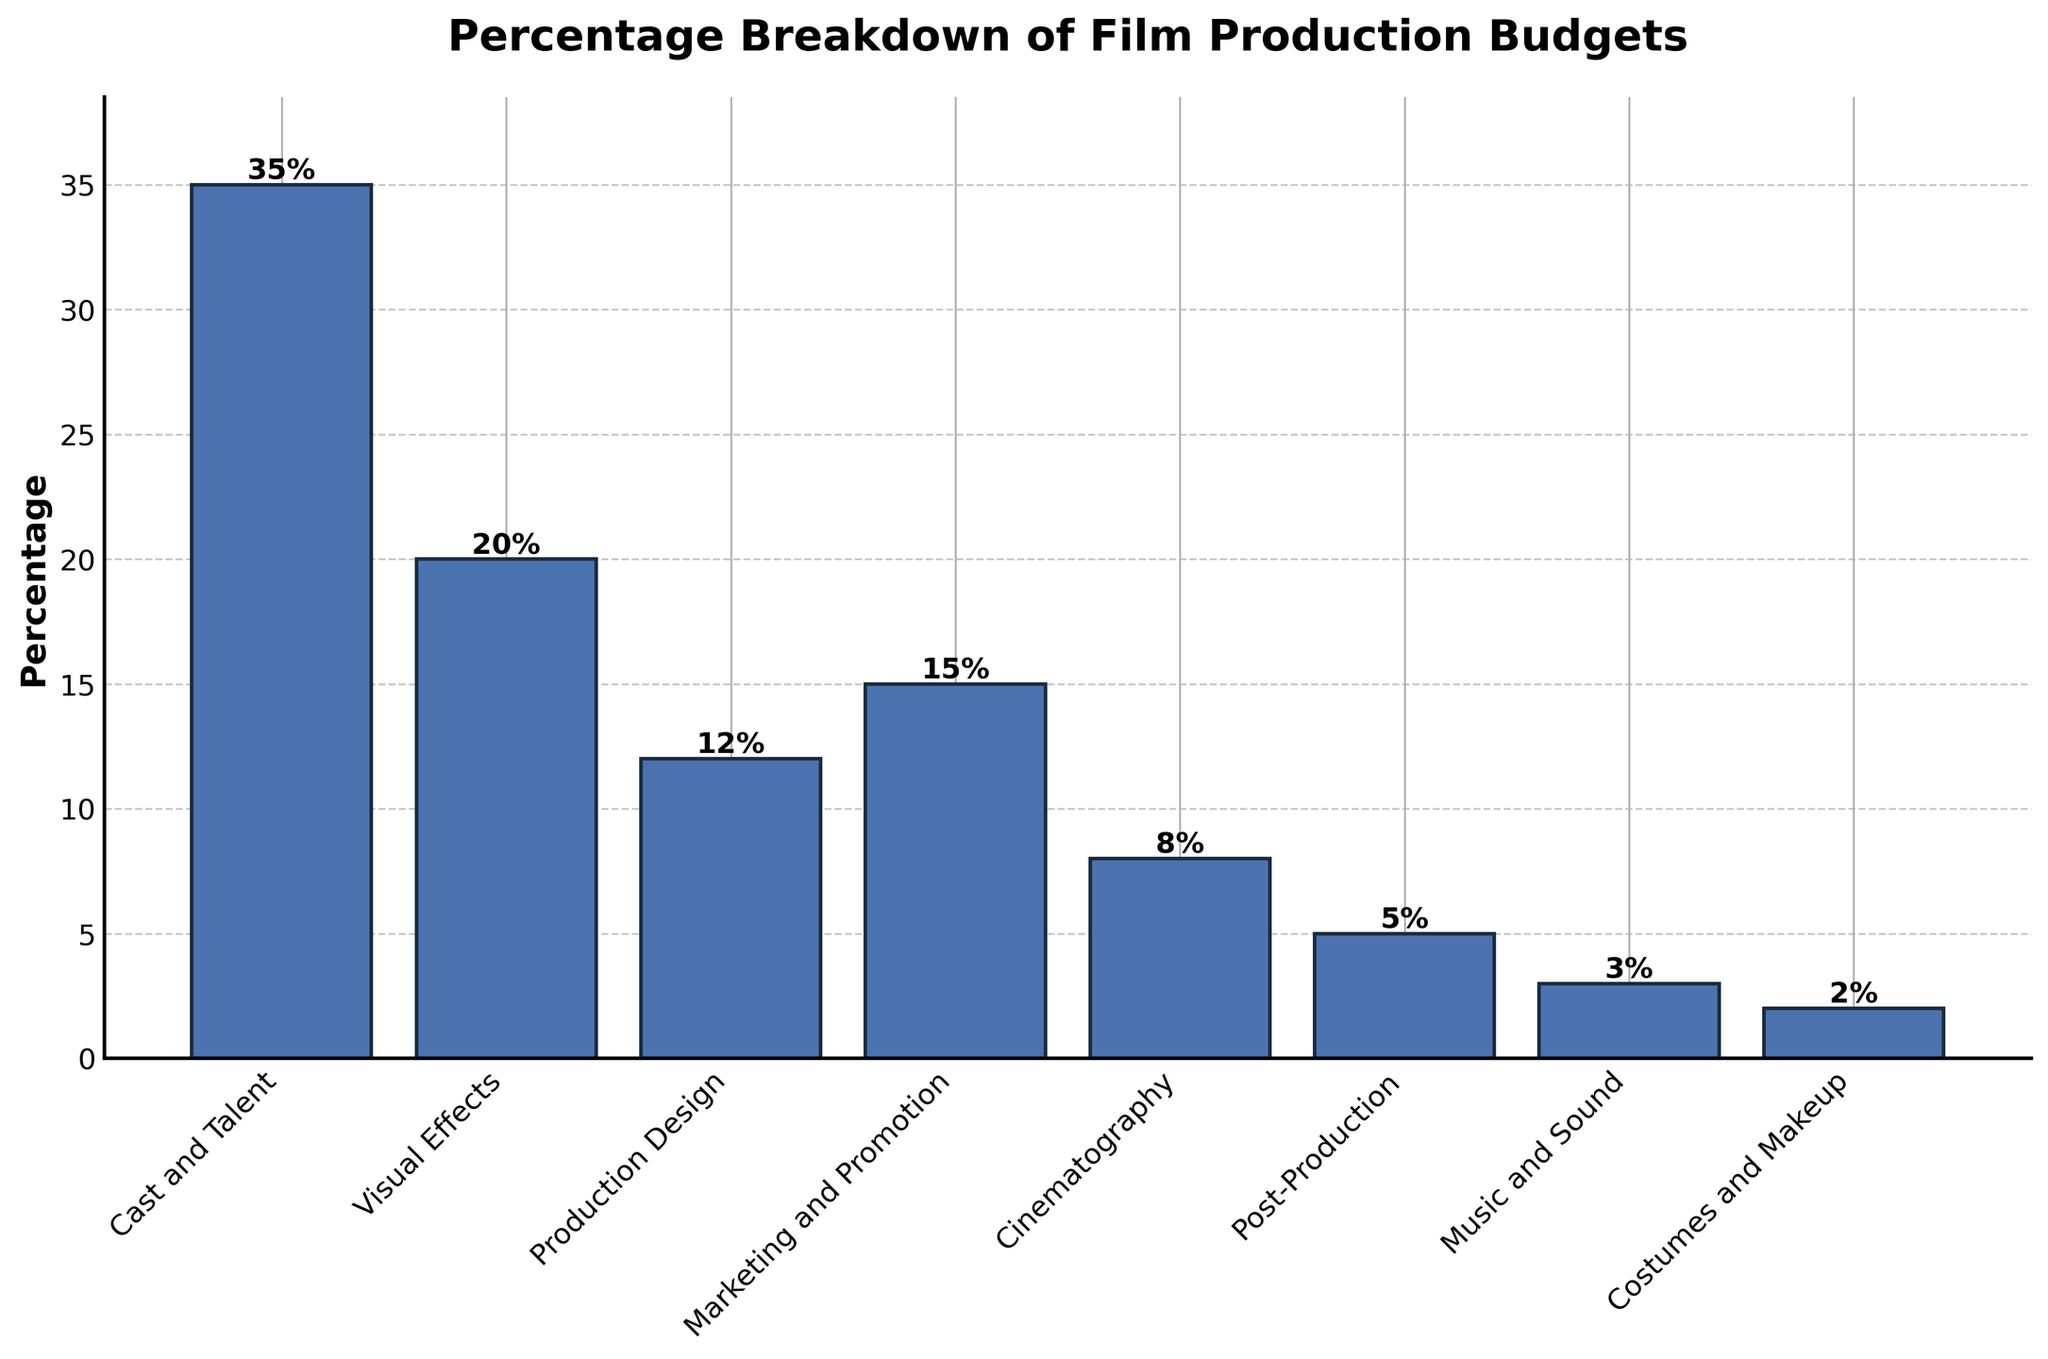What's the most expensive cost category in film production? The bar representing "Cast and Talent" is the tallest, indicating it's the most expensive cost category at 35%.
Answer: Cast and Talent Which category has the lowest budget allocation? The bar for "Costumes and Makeup" is the shortest, indicating it has the lowest budget allocation at 2%.
Answer: Costumes and Makeup How much higher is the percentage for Marketing and Promotion compared to Cinematography? The percentage for Marketing and Promotion is 15%, and for Cinematography, it is 8%. The difference is 15% - 8% = 7%.
Answer: 7% What is the total percentage allocated to post-production-related activities (Post-Production and Music and Sound)? Post-Production has 5% and Music and Sound has 3%. The total is 5% + 3% = 8%.
Answer: 8% If you sum the percentages for Cast and Talent, Visual Effects, and Production Design, what do you get? Cast and Talent is 35%, Visual Effects is 20%, and Production Design is 12%. Adding them together: 35% + 20% + 12% = 67%.
Answer: 67% Which category has a budget allocation closest to 10%? The category with the percentage closest to 10% is Cinematography with 8%.
Answer: Cinematography How does the percentage for Visual Effects compare to the percentage for Production Design? Visual Effects has a percentage of 20%, while Production Design has a percentage of 12%. Visual Effects is 8% higher than Production Design.
Answer: Visual Effects is higher What is the combined percentage of the three least expensive categories? The three least expensive categories are Costumes and Makeup (2%), Music and Sound (3%), and Post-Production (5%). The combined percentage is 2% + 3% + 5% = 10%.
Answer: 10% Is the budget for Marketing and Promotion greater than the combined budget for Production Design and Costumes and Makeup? Marketing and Promotion has a percentage of 15%. Production Design is 12% and Costumes and Makeup is 2%. The combined budget for Production Design and Costumes and Makeup is 12% + 2% = 14%, which is less than 15%.
Answer: Yes What's the difference in percentage between the most and least funded categories? The most funded category is Cast and Talent at 35%, and the least funded is Costumes and Makeup at 2%. The difference is 35% - 2% = 33%.
Answer: 33% 